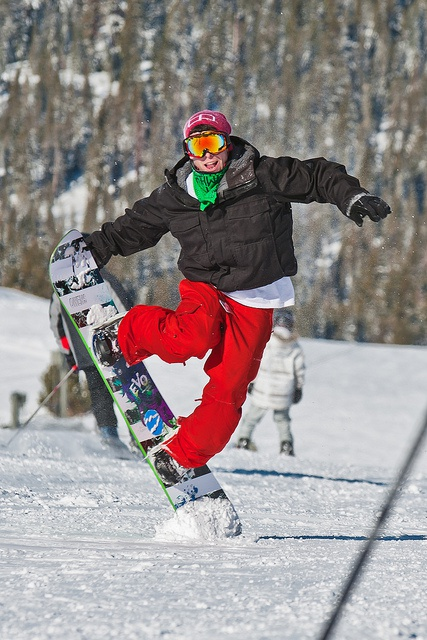Describe the objects in this image and their specific colors. I can see people in gray, black, red, brown, and maroon tones, snowboard in gray, lightgray, darkgray, and black tones, and people in gray, lightgray, darkgray, and maroon tones in this image. 